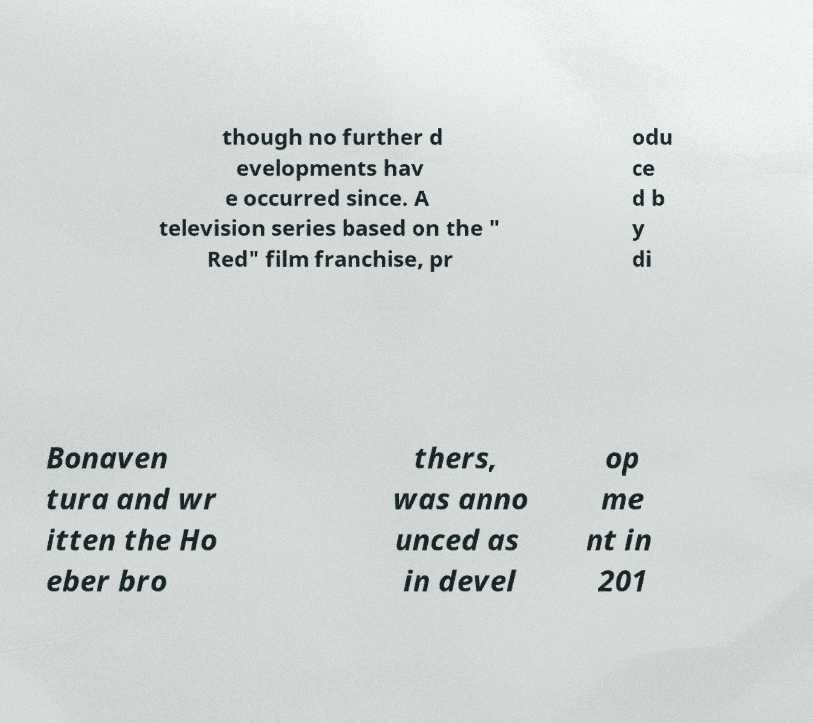Could you assist in decoding the text presented in this image and type it out clearly? though no further d evelopments hav e occurred since. A television series based on the " Red" film franchise, pr odu ce d b y di Bonaven tura and wr itten the Ho eber bro thers, was anno unced as in devel op me nt in 201 